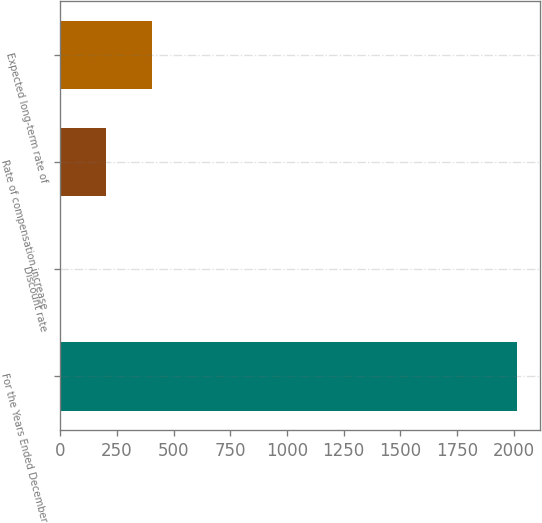<chart> <loc_0><loc_0><loc_500><loc_500><bar_chart><fcel>For the Years Ended December<fcel>Discount rate<fcel>Rate of compensation increase<fcel>Expected long-term rate of<nl><fcel>2013<fcel>2.13<fcel>203.22<fcel>404.31<nl></chart> 